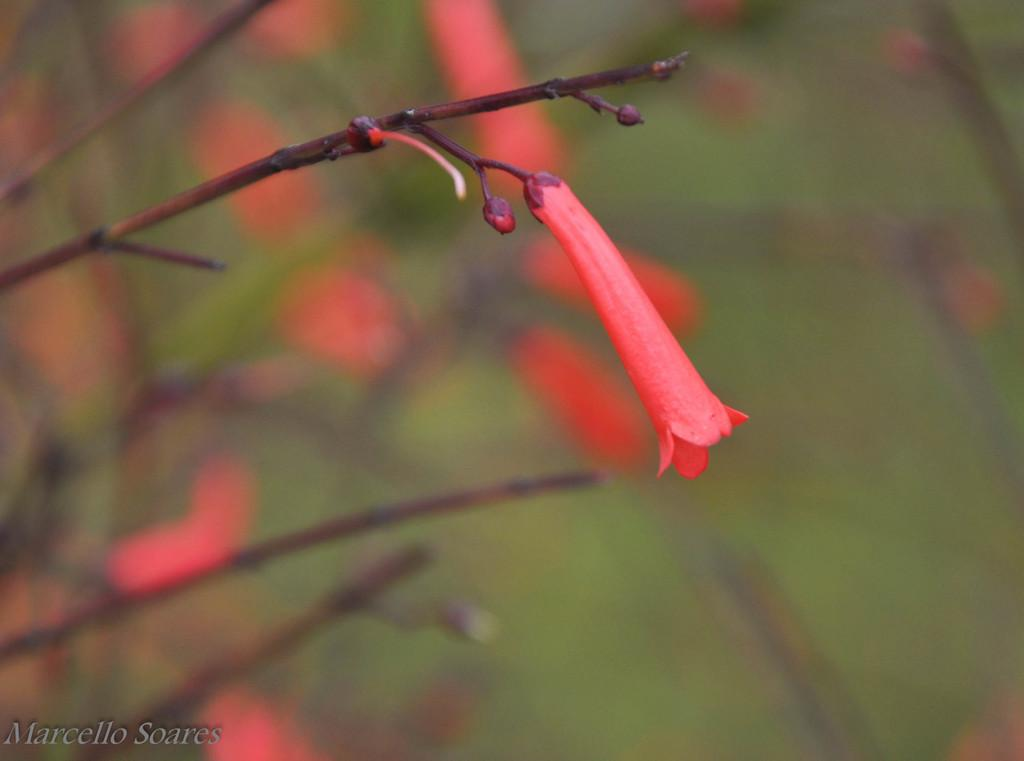What type of flowers can be seen in the image? There are red color flowers in the image. How would you describe the background of the image? The background of the image is blurred. Is there any additional information or marking on the image? Yes, there is a watermark on the bottom left side of the image. What type of news can be read from the balloon in the image? There is no balloon present in the image, and therefore no news can be read from it. 